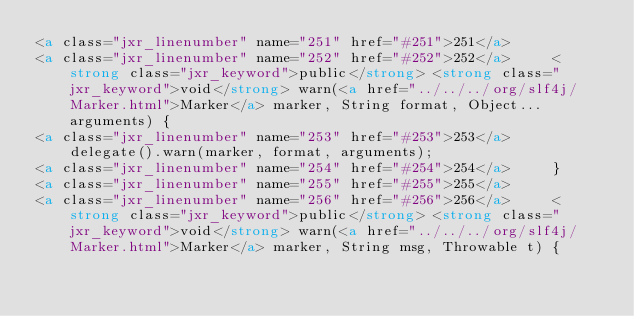Convert code to text. <code><loc_0><loc_0><loc_500><loc_500><_HTML_><a class="jxr_linenumber" name="251" href="#251">251</a> 
<a class="jxr_linenumber" name="252" href="#252">252</a>     <strong class="jxr_keyword">public</strong> <strong class="jxr_keyword">void</strong> warn(<a href="../../../org/slf4j/Marker.html">Marker</a> marker, String format, Object... arguments) {
<a class="jxr_linenumber" name="253" href="#253">253</a>         delegate().warn(marker, format, arguments);
<a class="jxr_linenumber" name="254" href="#254">254</a>     }
<a class="jxr_linenumber" name="255" href="#255">255</a> 
<a class="jxr_linenumber" name="256" href="#256">256</a>     <strong class="jxr_keyword">public</strong> <strong class="jxr_keyword">void</strong> warn(<a href="../../../org/slf4j/Marker.html">Marker</a> marker, String msg, Throwable t) {</code> 